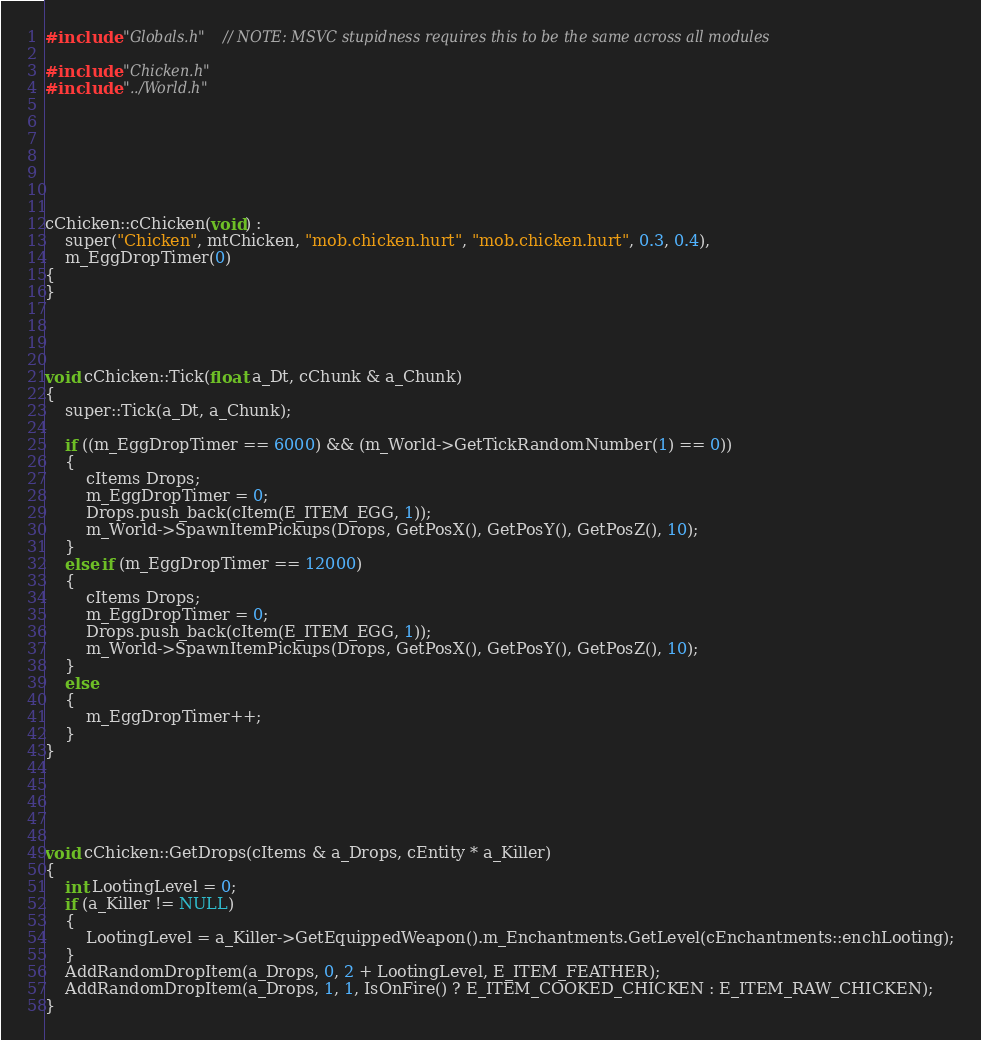<code> <loc_0><loc_0><loc_500><loc_500><_C++_>#include "Globals.h"  // NOTE: MSVC stupidness requires this to be the same across all modules

#include "Chicken.h"
#include "../World.h"







cChicken::cChicken(void) :
	super("Chicken", mtChicken, "mob.chicken.hurt", "mob.chicken.hurt", 0.3, 0.4),
	m_EggDropTimer(0)
{
}




void cChicken::Tick(float a_Dt, cChunk & a_Chunk)
{
	super::Tick(a_Dt, a_Chunk);

	if ((m_EggDropTimer == 6000) && (m_World->GetTickRandomNumber(1) == 0))
	{
		cItems Drops;
		m_EggDropTimer = 0;
		Drops.push_back(cItem(E_ITEM_EGG, 1));
		m_World->SpawnItemPickups(Drops, GetPosX(), GetPosY(), GetPosZ(), 10);
	}
	else if (m_EggDropTimer == 12000)
	{
		cItems Drops;
		m_EggDropTimer = 0;
		Drops.push_back(cItem(E_ITEM_EGG, 1));
		m_World->SpawnItemPickups(Drops, GetPosX(), GetPosY(), GetPosZ(), 10);
	}
	else
	{
		m_EggDropTimer++;
	}
}





void cChicken::GetDrops(cItems & a_Drops, cEntity * a_Killer)
{
	int LootingLevel = 0;
	if (a_Killer != NULL)
	{
		LootingLevel = a_Killer->GetEquippedWeapon().m_Enchantments.GetLevel(cEnchantments::enchLooting);
	}
	AddRandomDropItem(a_Drops, 0, 2 + LootingLevel, E_ITEM_FEATHER);
	AddRandomDropItem(a_Drops, 1, 1, IsOnFire() ? E_ITEM_COOKED_CHICKEN : E_ITEM_RAW_CHICKEN);
}








</code> 